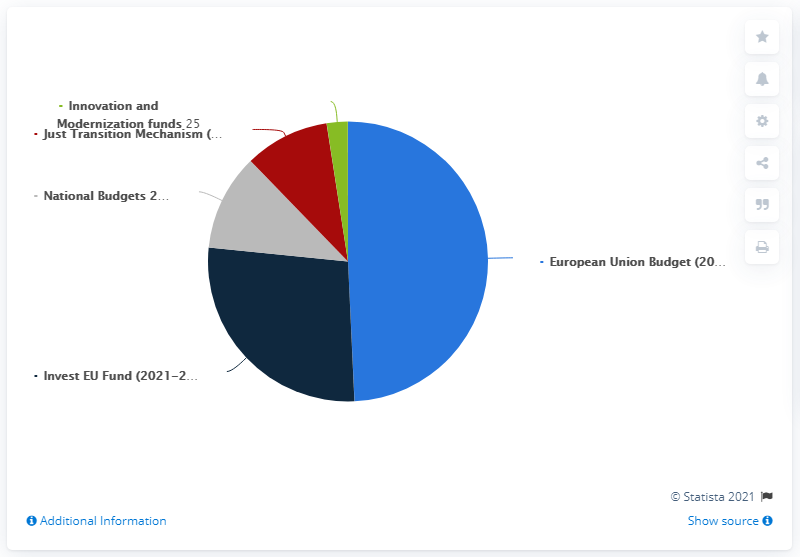Highlight a few significant elements in this photo. The Invest EU Fund leverages both private and public climate and environmentally-related investments to a significant degree. The Just Transition Mechanism is expected to mobilize significant investment in regions that are most exposed to transition challenges, up to a total of 100 million. The blue bar data mentioned in this context refers to the European Union Budget for the years 2021-2030. The Innovation and Modernization Fund will provide significant resources to enhance innovation and modernization in the power sector, totaling [amount] over [period of time]. To find the two largest investment plans from the pie chart, please refer to the information provided on the "Invest EU Fund (2021-2030) and European Union Budget (2021-2030)" sections of the pie chart. 